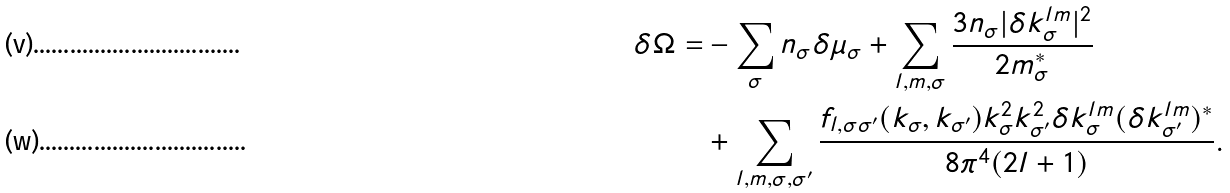<formula> <loc_0><loc_0><loc_500><loc_500>\delta \Omega = & - \sum _ { \sigma } n _ { \sigma } \delta \mu _ { \sigma } + \sum _ { l , m , \sigma } \frac { 3 n _ { \sigma } | \delta k _ { \sigma } ^ { l m } | ^ { 2 } } { 2 m _ { \sigma } ^ { * } } \\ & + \sum _ { l , m , \sigma , \sigma ^ { \prime } } \frac { f _ { l , \sigma \sigma ^ { \prime } } ( k _ { \sigma } , k _ { \sigma ^ { \prime } } ) k _ { \sigma } ^ { 2 } k _ { \sigma ^ { \prime } } ^ { 2 } \delta k _ { \sigma } ^ { l m } ( \delta k _ { \sigma ^ { \prime } } ^ { l m } ) ^ { * } } { 8 \pi ^ { 4 } ( 2 l + 1 ) } .</formula> 